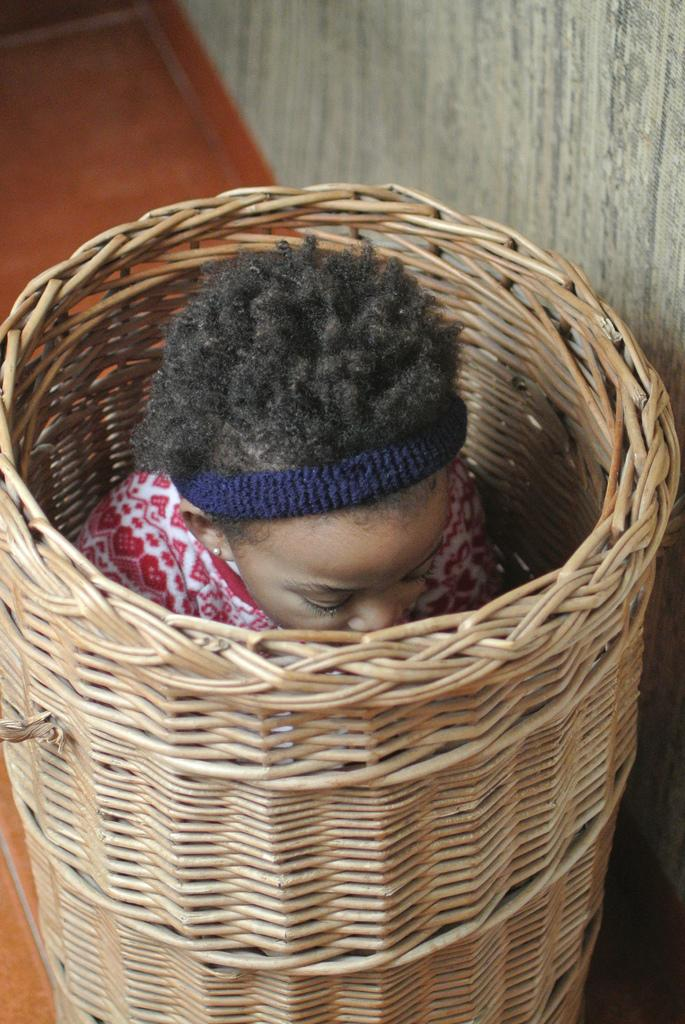Who is the main subject in the image? There is a girl in the image. What is the girl doing in the image? The girl is sitting in a basket. What type of peace symbol can be seen in the image? There is no peace symbol present in the image. How is the string used in the image? There is no string present in the image. 